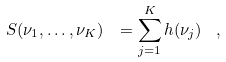Convert formula to latex. <formula><loc_0><loc_0><loc_500><loc_500>S ( \nu _ { 1 } , \dots , \nu _ { K } ) \ = \sum _ { j = 1 } ^ { K } h ( \nu _ { j } ) \, \ ,</formula> 